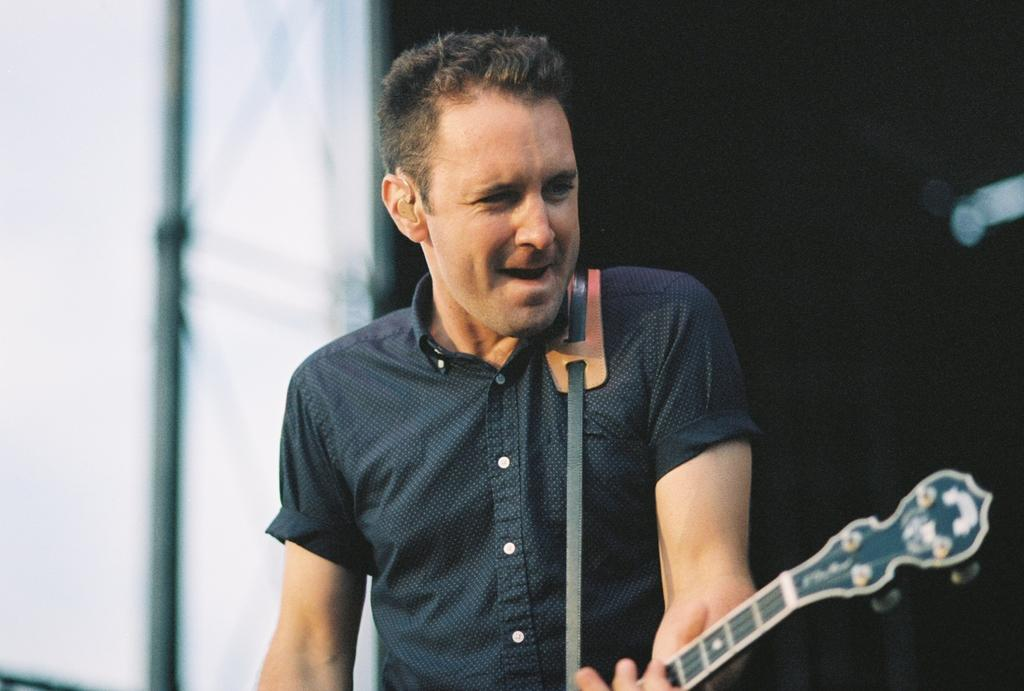Who is the main subject in the image? There is a man in the image. What is the man holding in his hand? The man is holding a guitar in his hand. Can you describe the background of the image? The background of the image is blurry. What type of water is being used by the company in the image? There is no mention of water or a company in the image; it features a man holding a guitar. 